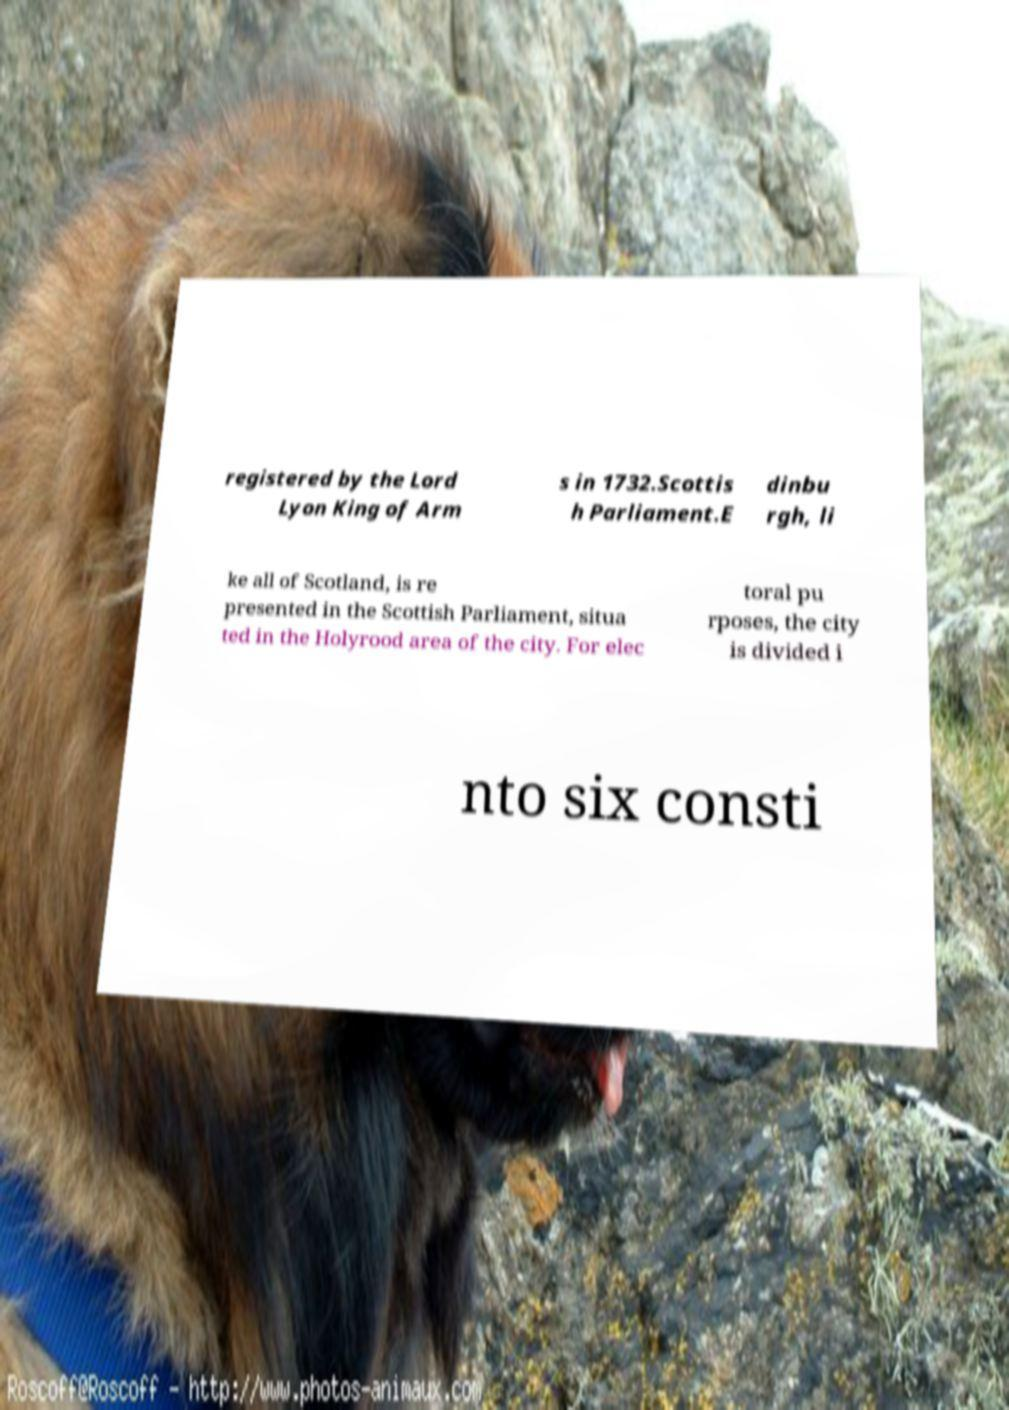What messages or text are displayed in this image? I need them in a readable, typed format. registered by the Lord Lyon King of Arm s in 1732.Scottis h Parliament.E dinbu rgh, li ke all of Scotland, is re presented in the Scottish Parliament, situa ted in the Holyrood area of the city. For elec toral pu rposes, the city is divided i nto six consti 